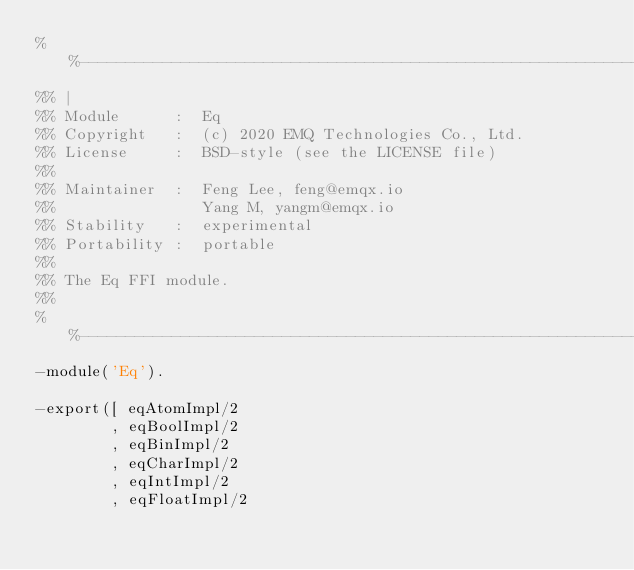<code> <loc_0><loc_0><loc_500><loc_500><_Erlang_>%%---------------------------------------------------------------------------
%% |
%% Module      :  Eq
%% Copyright   :  (c) 2020 EMQ Technologies Co., Ltd.
%% License     :  BSD-style (see the LICENSE file)
%%
%% Maintainer  :  Feng Lee, feng@emqx.io
%%                Yang M, yangm@emqx.io
%% Stability   :  experimental
%% Portability :  portable
%%
%% The Eq FFI module.
%%
%%---------------------------------------------------------------------------
-module('Eq').

-export([ eqAtomImpl/2
        , eqBoolImpl/2
        , eqBinImpl/2
        , eqCharImpl/2
        , eqIntImpl/2
        , eqFloatImpl/2</code> 